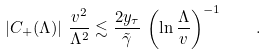Convert formula to latex. <formula><loc_0><loc_0><loc_500><loc_500>\left | C _ { + } ( \Lambda ) \right | \, \frac { v ^ { 2 } } { \Lambda ^ { 2 } } \lesssim \frac { 2 y _ { \tau } } { \tilde { \gamma } } \, \left ( \ln \frac { \Lambda } { v } \right ) ^ { - 1 } \quad .</formula> 